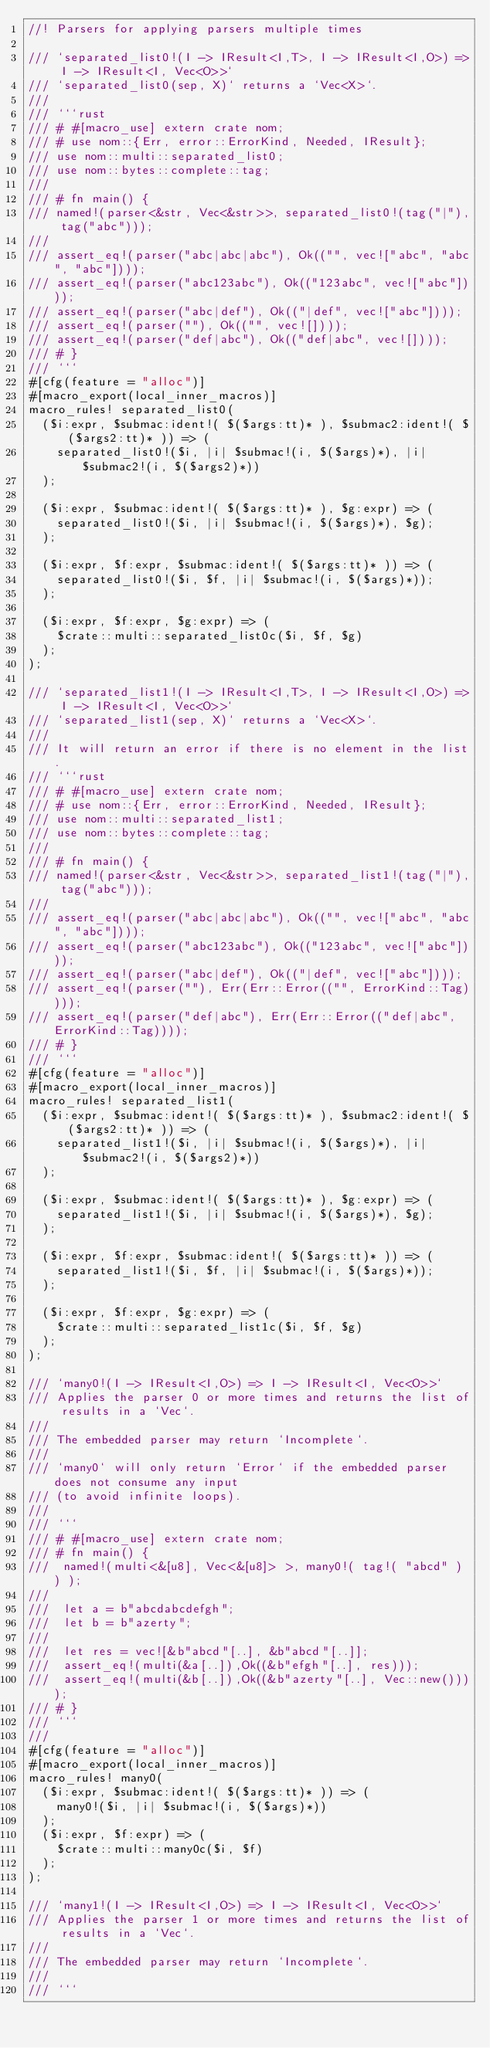<code> <loc_0><loc_0><loc_500><loc_500><_Rust_>//! Parsers for applying parsers multiple times

/// `separated_list0!(I -> IResult<I,T>, I -> IResult<I,O>) => I -> IResult<I, Vec<O>>`
/// `separated_list0(sep, X)` returns a `Vec<X>`.
///
/// ```rust
/// # #[macro_use] extern crate nom;
/// # use nom::{Err, error::ErrorKind, Needed, IResult};
/// use nom::multi::separated_list0;
/// use nom::bytes::complete::tag;
///
/// # fn main() {
/// named!(parser<&str, Vec<&str>>, separated_list0!(tag("|"), tag("abc")));
///
/// assert_eq!(parser("abc|abc|abc"), Ok(("", vec!["abc", "abc", "abc"])));
/// assert_eq!(parser("abc123abc"), Ok(("123abc", vec!["abc"])));
/// assert_eq!(parser("abc|def"), Ok(("|def", vec!["abc"])));
/// assert_eq!(parser(""), Ok(("", vec![])));
/// assert_eq!(parser("def|abc"), Ok(("def|abc", vec![])));
/// # }
/// ```
#[cfg(feature = "alloc")]
#[macro_export(local_inner_macros)]
macro_rules! separated_list0(
  ($i:expr, $submac:ident!( $($args:tt)* ), $submac2:ident!( $($args2:tt)* )) => (
    separated_list0!($i, |i| $submac!(i, $($args)*), |i| $submac2!(i, $($args2)*))
  );

  ($i:expr, $submac:ident!( $($args:tt)* ), $g:expr) => (
    separated_list0!($i, |i| $submac!(i, $($args)*), $g);
  );

  ($i:expr, $f:expr, $submac:ident!( $($args:tt)* )) => (
    separated_list0!($i, $f, |i| $submac!(i, $($args)*));
  );

  ($i:expr, $f:expr, $g:expr) => (
    $crate::multi::separated_list0c($i, $f, $g)
  );
);

/// `separated_list1!(I -> IResult<I,T>, I -> IResult<I,O>) => I -> IResult<I, Vec<O>>`
/// `separated_list1(sep, X)` returns a `Vec<X>`.
///
/// It will return an error if there is no element in the list.
/// ```rust
/// # #[macro_use] extern crate nom;
/// # use nom::{Err, error::ErrorKind, Needed, IResult};
/// use nom::multi::separated_list1;
/// use nom::bytes::complete::tag;
///
/// # fn main() {
/// named!(parser<&str, Vec<&str>>, separated_list1!(tag("|"), tag("abc")));
///
/// assert_eq!(parser("abc|abc|abc"), Ok(("", vec!["abc", "abc", "abc"])));
/// assert_eq!(parser("abc123abc"), Ok(("123abc", vec!["abc"])));
/// assert_eq!(parser("abc|def"), Ok(("|def", vec!["abc"])));
/// assert_eq!(parser(""), Err(Err::Error(("", ErrorKind::Tag))));
/// assert_eq!(parser("def|abc"), Err(Err::Error(("def|abc", ErrorKind::Tag))));
/// # }
/// ```
#[cfg(feature = "alloc")]
#[macro_export(local_inner_macros)]
macro_rules! separated_list1(
  ($i:expr, $submac:ident!( $($args:tt)* ), $submac2:ident!( $($args2:tt)* )) => (
    separated_list1!($i, |i| $submac!(i, $($args)*), |i| $submac2!(i, $($args2)*))
  );

  ($i:expr, $submac:ident!( $($args:tt)* ), $g:expr) => (
    separated_list1!($i, |i| $submac!(i, $($args)*), $g);
  );

  ($i:expr, $f:expr, $submac:ident!( $($args:tt)* )) => (
    separated_list1!($i, $f, |i| $submac!(i, $($args)*));
  );

  ($i:expr, $f:expr, $g:expr) => (
    $crate::multi::separated_list1c($i, $f, $g)
  );
);

/// `many0!(I -> IResult<I,O>) => I -> IResult<I, Vec<O>>`
/// Applies the parser 0 or more times and returns the list of results in a `Vec`.
///
/// The embedded parser may return `Incomplete`.
///
/// `many0` will only return `Error` if the embedded parser does not consume any input
/// (to avoid infinite loops).
///
/// ```
/// # #[macro_use] extern crate nom;
/// # fn main() {
///  named!(multi<&[u8], Vec<&[u8]> >, many0!( tag!( "abcd" ) ) );
///
///  let a = b"abcdabcdefgh";
///  let b = b"azerty";
///
///  let res = vec![&b"abcd"[..], &b"abcd"[..]];
///  assert_eq!(multi(&a[..]),Ok((&b"efgh"[..], res)));
///  assert_eq!(multi(&b[..]),Ok((&b"azerty"[..], Vec::new())));
/// # }
/// ```
///
#[cfg(feature = "alloc")]
#[macro_export(local_inner_macros)]
macro_rules! many0(
  ($i:expr, $submac:ident!( $($args:tt)* )) => (
    many0!($i, |i| $submac!(i, $($args)*))
  );
  ($i:expr, $f:expr) => (
    $crate::multi::many0c($i, $f)
  );
);

/// `many1!(I -> IResult<I,O>) => I -> IResult<I, Vec<O>>`
/// Applies the parser 1 or more times and returns the list of results in a `Vec`.
///
/// The embedded parser may return `Incomplete`.
///
/// ```</code> 